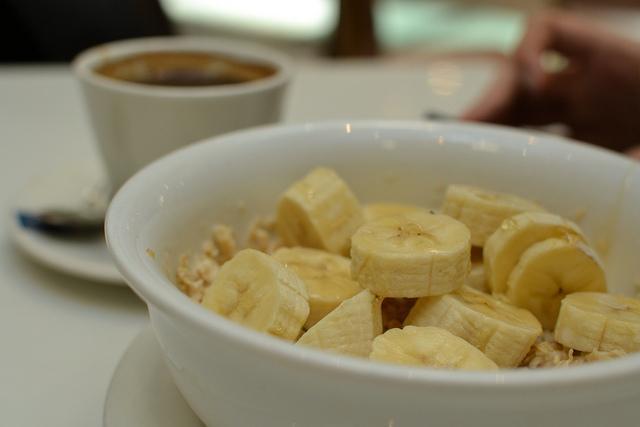How many cups are there?
Give a very brief answer. 1. How many buses on the road?
Give a very brief answer. 0. 